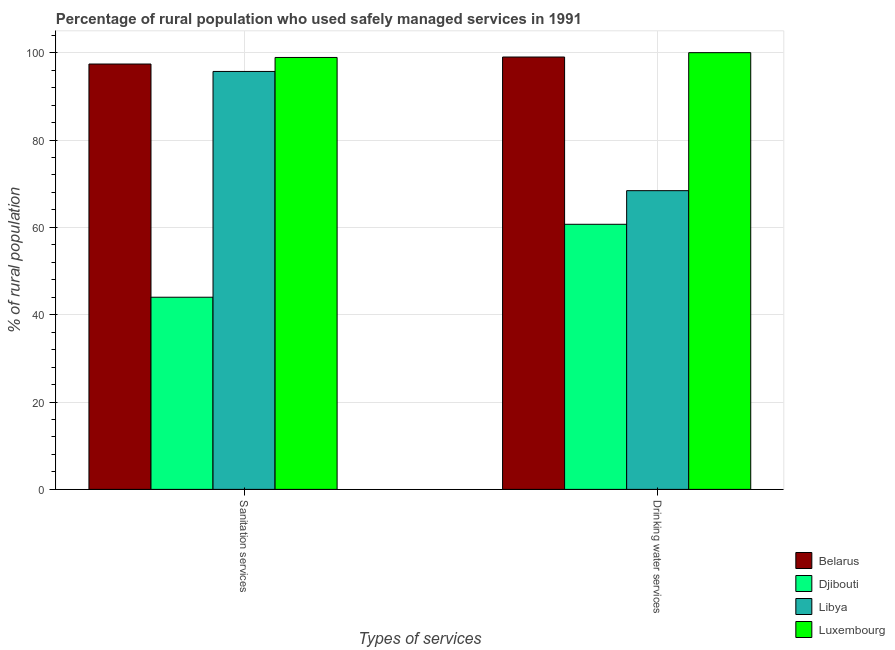How many groups of bars are there?
Keep it short and to the point. 2. Are the number of bars per tick equal to the number of legend labels?
Keep it short and to the point. Yes. How many bars are there on the 1st tick from the right?
Offer a very short reply. 4. What is the label of the 1st group of bars from the left?
Make the answer very short. Sanitation services. What is the percentage of rural population who used drinking water services in Djibouti?
Provide a succinct answer. 60.7. Across all countries, what is the maximum percentage of rural population who used sanitation services?
Make the answer very short. 98.9. Across all countries, what is the minimum percentage of rural population who used sanitation services?
Your answer should be very brief. 44. In which country was the percentage of rural population who used drinking water services maximum?
Offer a terse response. Luxembourg. In which country was the percentage of rural population who used sanitation services minimum?
Ensure brevity in your answer.  Djibouti. What is the total percentage of rural population who used drinking water services in the graph?
Provide a short and direct response. 328.1. What is the difference between the percentage of rural population who used sanitation services in Luxembourg and that in Libya?
Provide a succinct answer. 3.2. What is the difference between the percentage of rural population who used drinking water services in Luxembourg and the percentage of rural population who used sanitation services in Belarus?
Ensure brevity in your answer.  2.6. What is the difference between the percentage of rural population who used drinking water services and percentage of rural population who used sanitation services in Djibouti?
Provide a short and direct response. 16.7. In how many countries, is the percentage of rural population who used drinking water services greater than 28 %?
Keep it short and to the point. 4. What is the ratio of the percentage of rural population who used drinking water services in Belarus to that in Djibouti?
Your answer should be compact. 1.63. Is the percentage of rural population who used drinking water services in Belarus less than that in Djibouti?
Provide a short and direct response. No. What does the 2nd bar from the left in Drinking water services represents?
Keep it short and to the point. Djibouti. What does the 3rd bar from the right in Drinking water services represents?
Ensure brevity in your answer.  Djibouti. How many bars are there?
Ensure brevity in your answer.  8. Are all the bars in the graph horizontal?
Provide a succinct answer. No. How many countries are there in the graph?
Keep it short and to the point. 4. What is the difference between two consecutive major ticks on the Y-axis?
Your answer should be very brief. 20. Are the values on the major ticks of Y-axis written in scientific E-notation?
Make the answer very short. No. Does the graph contain grids?
Offer a terse response. Yes. Where does the legend appear in the graph?
Provide a short and direct response. Bottom right. How are the legend labels stacked?
Make the answer very short. Vertical. What is the title of the graph?
Offer a terse response. Percentage of rural population who used safely managed services in 1991. What is the label or title of the X-axis?
Your response must be concise. Types of services. What is the label or title of the Y-axis?
Your answer should be compact. % of rural population. What is the % of rural population in Belarus in Sanitation services?
Provide a short and direct response. 97.4. What is the % of rural population in Libya in Sanitation services?
Provide a succinct answer. 95.7. What is the % of rural population in Luxembourg in Sanitation services?
Keep it short and to the point. 98.9. What is the % of rural population of Belarus in Drinking water services?
Your answer should be very brief. 99. What is the % of rural population of Djibouti in Drinking water services?
Your response must be concise. 60.7. What is the % of rural population of Libya in Drinking water services?
Ensure brevity in your answer.  68.4. What is the % of rural population of Luxembourg in Drinking water services?
Give a very brief answer. 100. Across all Types of services, what is the maximum % of rural population of Djibouti?
Offer a terse response. 60.7. Across all Types of services, what is the maximum % of rural population in Libya?
Make the answer very short. 95.7. Across all Types of services, what is the maximum % of rural population in Luxembourg?
Ensure brevity in your answer.  100. Across all Types of services, what is the minimum % of rural population in Belarus?
Provide a succinct answer. 97.4. Across all Types of services, what is the minimum % of rural population in Libya?
Provide a short and direct response. 68.4. Across all Types of services, what is the minimum % of rural population in Luxembourg?
Your response must be concise. 98.9. What is the total % of rural population of Belarus in the graph?
Your answer should be compact. 196.4. What is the total % of rural population of Djibouti in the graph?
Your response must be concise. 104.7. What is the total % of rural population in Libya in the graph?
Provide a succinct answer. 164.1. What is the total % of rural population in Luxembourg in the graph?
Offer a terse response. 198.9. What is the difference between the % of rural population in Djibouti in Sanitation services and that in Drinking water services?
Your answer should be very brief. -16.7. What is the difference between the % of rural population in Libya in Sanitation services and that in Drinking water services?
Provide a short and direct response. 27.3. What is the difference between the % of rural population in Belarus in Sanitation services and the % of rural population in Djibouti in Drinking water services?
Make the answer very short. 36.7. What is the difference between the % of rural population in Belarus in Sanitation services and the % of rural population in Luxembourg in Drinking water services?
Ensure brevity in your answer.  -2.6. What is the difference between the % of rural population in Djibouti in Sanitation services and the % of rural population in Libya in Drinking water services?
Make the answer very short. -24.4. What is the difference between the % of rural population of Djibouti in Sanitation services and the % of rural population of Luxembourg in Drinking water services?
Give a very brief answer. -56. What is the average % of rural population of Belarus per Types of services?
Ensure brevity in your answer.  98.2. What is the average % of rural population of Djibouti per Types of services?
Your response must be concise. 52.35. What is the average % of rural population in Libya per Types of services?
Provide a succinct answer. 82.05. What is the average % of rural population of Luxembourg per Types of services?
Offer a very short reply. 99.45. What is the difference between the % of rural population in Belarus and % of rural population in Djibouti in Sanitation services?
Provide a succinct answer. 53.4. What is the difference between the % of rural population of Djibouti and % of rural population of Libya in Sanitation services?
Give a very brief answer. -51.7. What is the difference between the % of rural population of Djibouti and % of rural population of Luxembourg in Sanitation services?
Provide a succinct answer. -54.9. What is the difference between the % of rural population of Libya and % of rural population of Luxembourg in Sanitation services?
Keep it short and to the point. -3.2. What is the difference between the % of rural population in Belarus and % of rural population in Djibouti in Drinking water services?
Your answer should be very brief. 38.3. What is the difference between the % of rural population in Belarus and % of rural population in Libya in Drinking water services?
Your answer should be compact. 30.6. What is the difference between the % of rural population of Belarus and % of rural population of Luxembourg in Drinking water services?
Your answer should be very brief. -1. What is the difference between the % of rural population of Djibouti and % of rural population of Luxembourg in Drinking water services?
Your answer should be very brief. -39.3. What is the difference between the % of rural population of Libya and % of rural population of Luxembourg in Drinking water services?
Your answer should be compact. -31.6. What is the ratio of the % of rural population in Belarus in Sanitation services to that in Drinking water services?
Keep it short and to the point. 0.98. What is the ratio of the % of rural population in Djibouti in Sanitation services to that in Drinking water services?
Provide a succinct answer. 0.72. What is the ratio of the % of rural population in Libya in Sanitation services to that in Drinking water services?
Give a very brief answer. 1.4. What is the difference between the highest and the second highest % of rural population of Djibouti?
Keep it short and to the point. 16.7. What is the difference between the highest and the second highest % of rural population in Libya?
Give a very brief answer. 27.3. What is the difference between the highest and the second highest % of rural population of Luxembourg?
Keep it short and to the point. 1.1. What is the difference between the highest and the lowest % of rural population in Belarus?
Make the answer very short. 1.6. What is the difference between the highest and the lowest % of rural population of Libya?
Keep it short and to the point. 27.3. What is the difference between the highest and the lowest % of rural population in Luxembourg?
Your answer should be very brief. 1.1. 